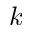<formula> <loc_0><loc_0><loc_500><loc_500>k</formula> 